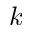<formula> <loc_0><loc_0><loc_500><loc_500>k</formula> 